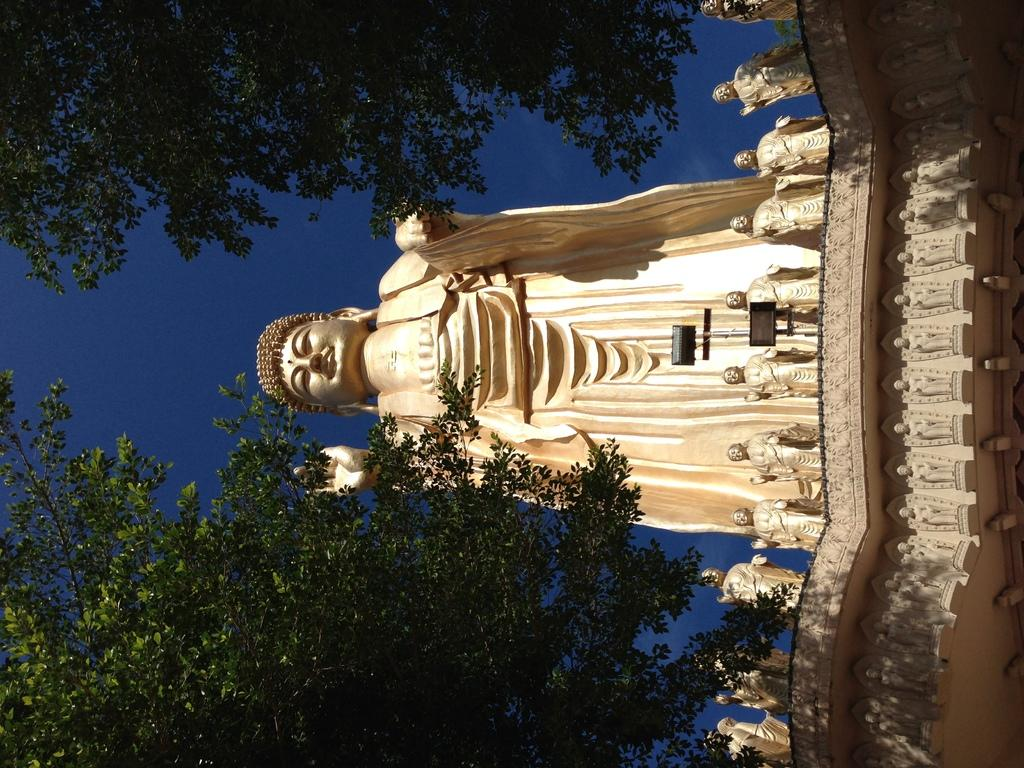What type of objects can be seen in the image? There are statues in the image. What else is present in the image besides the statues? There are lights and trees in the image. What is your mom doing while reading in the image? There is no mention of a mom or reading in the image; it features statues, lights, and trees. 